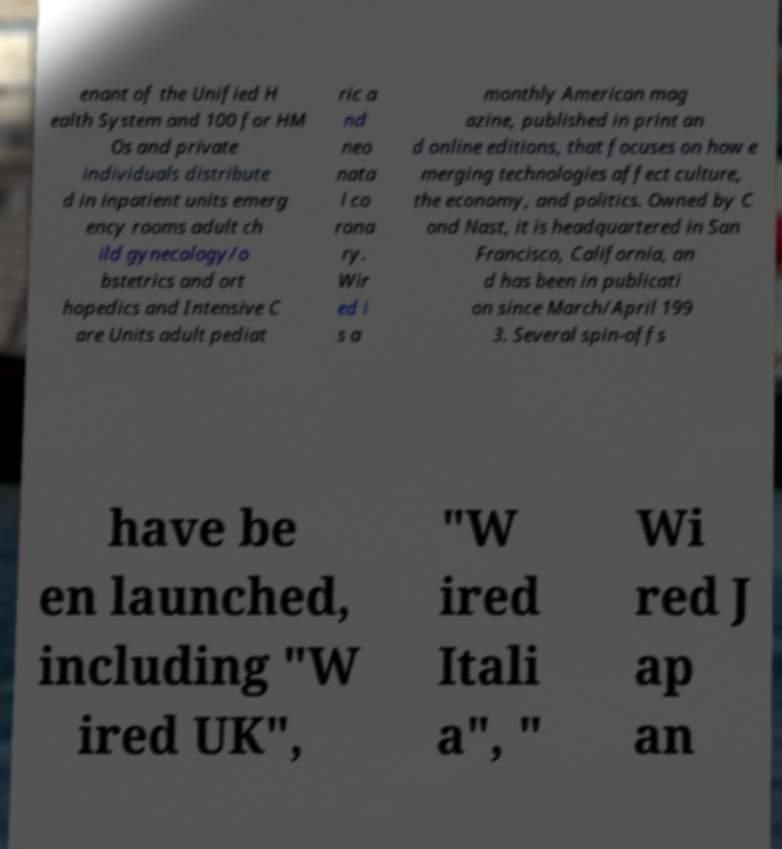For documentation purposes, I need the text within this image transcribed. Could you provide that? enant of the Unified H ealth System and 100 for HM Os and private individuals distribute d in inpatient units emerg ency rooms adult ch ild gynecology/o bstetrics and ort hopedics and Intensive C are Units adult pediat ric a nd neo nata l co rona ry. Wir ed i s a monthly American mag azine, published in print an d online editions, that focuses on how e merging technologies affect culture, the economy, and politics. Owned by C ond Nast, it is headquartered in San Francisco, California, an d has been in publicati on since March/April 199 3. Several spin-offs have be en launched, including "W ired UK", "W ired Itali a", " Wi red J ap an 